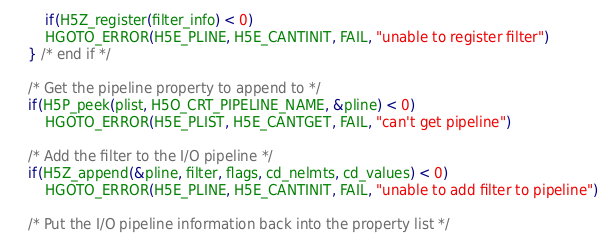Convert code to text. <code><loc_0><loc_0><loc_500><loc_500><_C_>        if(H5Z_register(filter_info) < 0)
	    HGOTO_ERROR(H5E_PLINE, H5E_CANTINIT, FAIL, "unable to register filter")
    } /* end if */

    /* Get the pipeline property to append to */
    if(H5P_peek(plist, H5O_CRT_PIPELINE_NAME, &pline) < 0)
        HGOTO_ERROR(H5E_PLIST, H5E_CANTGET, FAIL, "can't get pipeline")

    /* Add the filter to the I/O pipeline */
    if(H5Z_append(&pline, filter, flags, cd_nelmts, cd_values) < 0)
        HGOTO_ERROR(H5E_PLINE, H5E_CANTINIT, FAIL, "unable to add filter to pipeline")

    /* Put the I/O pipeline information back into the property list */</code> 